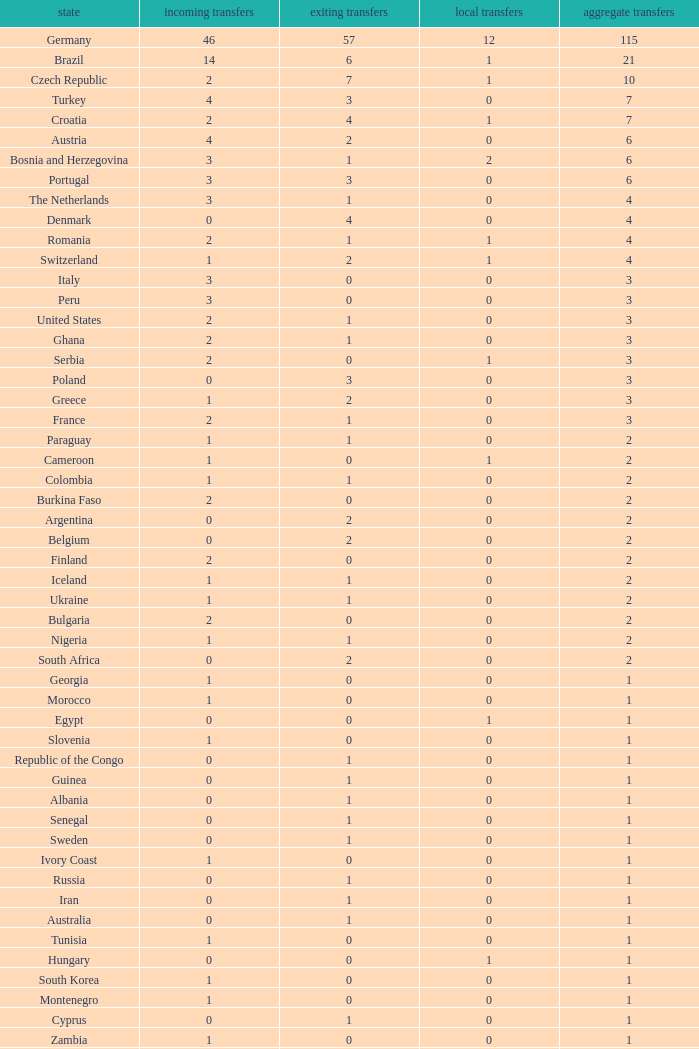What are the transfers in for Hungary? 0.0. 